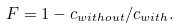<formula> <loc_0><loc_0><loc_500><loc_500>F = 1 - c _ { w i t h o u t } / c _ { w i t h } .</formula> 